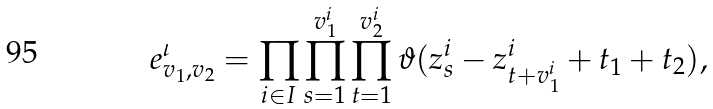Convert formula to latex. <formula><loc_0><loc_0><loc_500><loc_500>e _ { v _ { 1 } , v _ { 2 } } ^ { \iota } = \prod _ { i \in I } \prod _ { s = 1 } ^ { v _ { 1 } ^ { i } } \prod _ { t = 1 } ^ { v _ { 2 } ^ { i } } \vartheta ( z ^ { i } _ { s } - z ^ { i } _ { t + v _ { 1 } ^ { i } } + t _ { 1 } + t _ { 2 } ) ,</formula> 